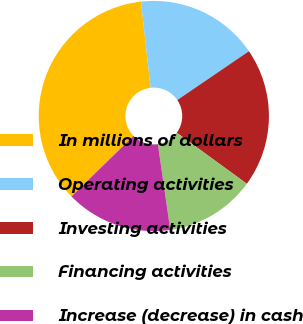<chart> <loc_0><loc_0><loc_500><loc_500><pie_chart><fcel>In millions of dollars<fcel>Operating activities<fcel>Investing activities<fcel>Financing activities<fcel>Increase (decrease) in cash<nl><fcel>35.53%<fcel>17.26%<fcel>19.54%<fcel>12.69%<fcel>14.97%<nl></chart> 